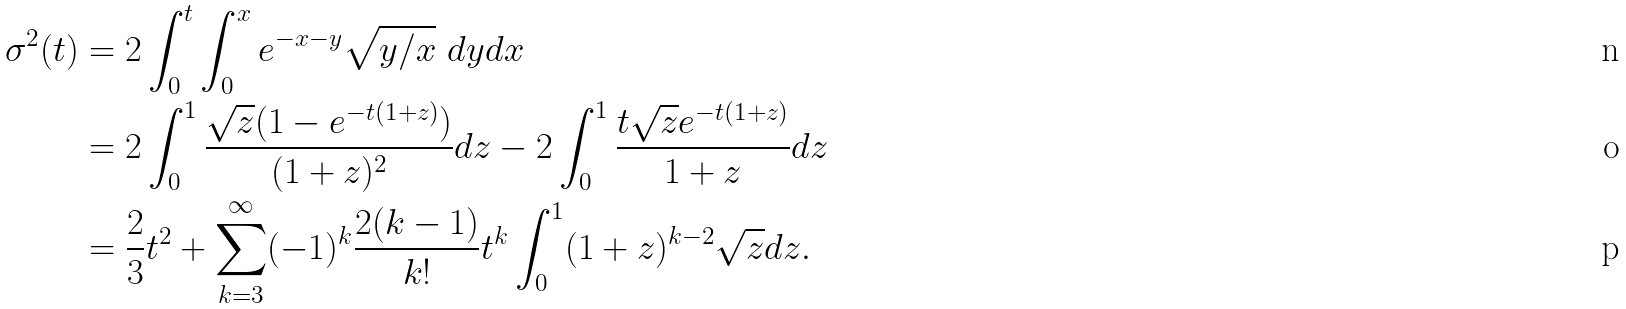Convert formula to latex. <formula><loc_0><loc_0><loc_500><loc_500>\sigma ^ { 2 } ( t ) & = 2 \int _ { 0 } ^ { t } \int _ { 0 } ^ { x } e ^ { - x - y } \sqrt { y / x } \ d y d x \\ & = 2 \int _ { 0 } ^ { 1 } \frac { \sqrt { z } ( 1 - e ^ { - t ( 1 + z ) } ) } { ( 1 + z ) ^ { 2 } } d z - 2 \int _ { 0 } ^ { 1 } \frac { t \sqrt { z } e ^ { - t ( 1 + z ) } } { 1 + z } d z \\ & = \frac { 2 } { 3 } t ^ { 2 } + \sum _ { k = 3 } ^ { \infty } ( - 1 ) ^ { k } \frac { 2 ( k - 1 ) } { k ! } t ^ { k } \int _ { 0 } ^ { 1 } ( 1 + z ) ^ { k - 2 } \sqrt { z } d z .</formula> 